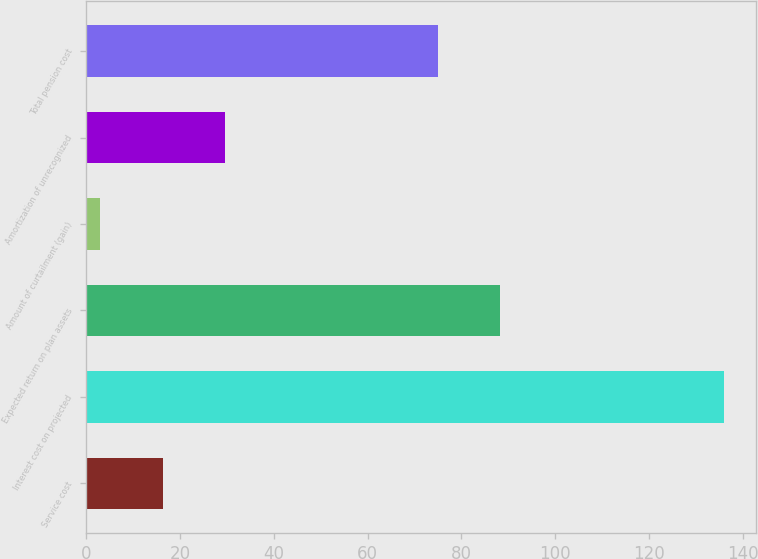Convert chart. <chart><loc_0><loc_0><loc_500><loc_500><bar_chart><fcel>Service cost<fcel>Interest cost on projected<fcel>Expected return on plan assets<fcel>Amount of curtailment (gain)<fcel>Amortization of unrecognized<fcel>Total pension cost<nl><fcel>16.3<fcel>136<fcel>88.3<fcel>3<fcel>29.6<fcel>75<nl></chart> 